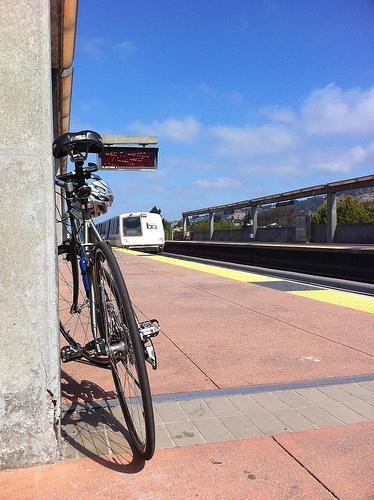How many bikes?
Give a very brief answer. 1. How many wheels are on the bike?
Give a very brief answer. 2. 